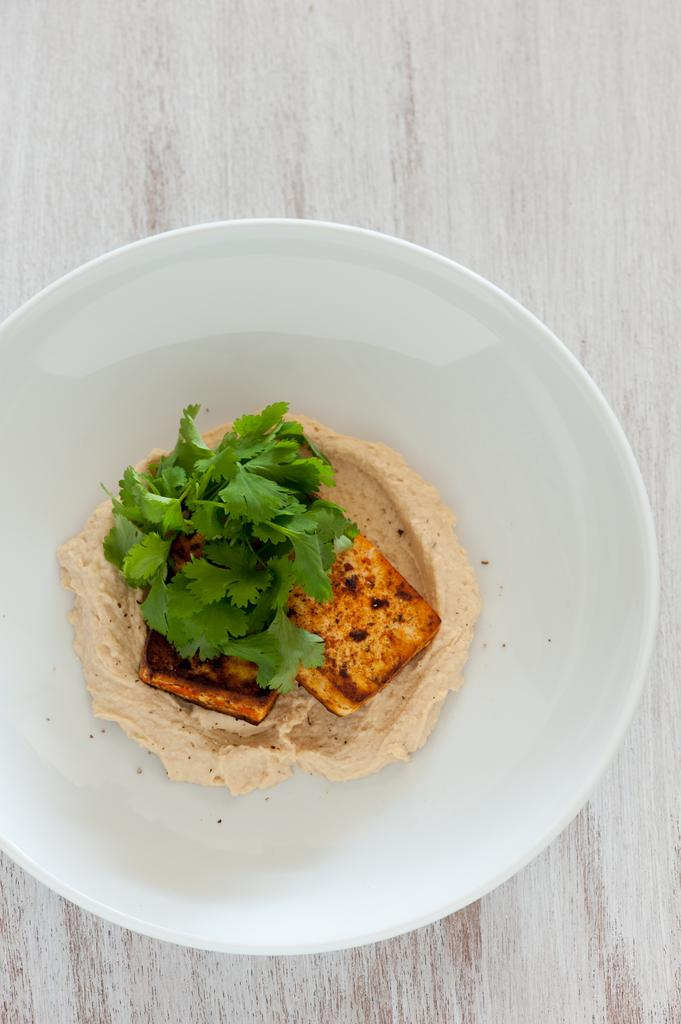What is on the plate in the image? There is food in the plate in the image. What can be seen in the background of the image? There is a table in the background of the image. What type of pan is being used to cook the milk in the image? There is no pan or milk present in the image; it only features a plate of food and a table in the background. 